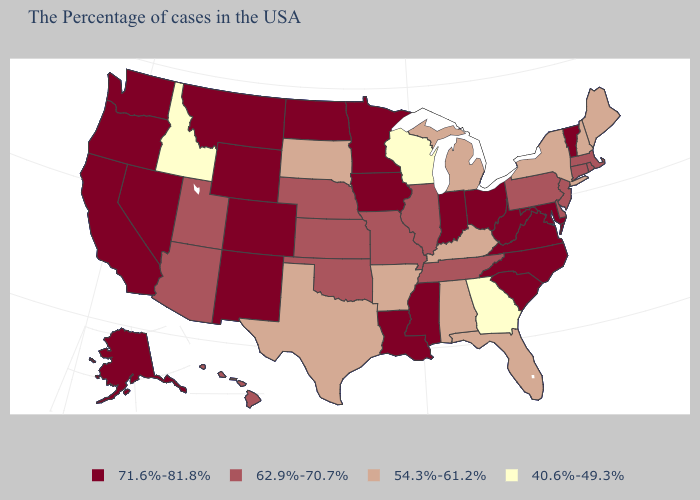Name the states that have a value in the range 40.6%-49.3%?
Write a very short answer. Georgia, Wisconsin, Idaho. Does Ohio have a lower value than North Carolina?
Quick response, please. No. Name the states that have a value in the range 71.6%-81.8%?
Keep it brief. Vermont, Maryland, Virginia, North Carolina, South Carolina, West Virginia, Ohio, Indiana, Mississippi, Louisiana, Minnesota, Iowa, North Dakota, Wyoming, Colorado, New Mexico, Montana, Nevada, California, Washington, Oregon, Alaska. What is the value of South Carolina?
Be succinct. 71.6%-81.8%. Does the map have missing data?
Answer briefly. No. Name the states that have a value in the range 62.9%-70.7%?
Write a very short answer. Massachusetts, Rhode Island, Connecticut, New Jersey, Delaware, Pennsylvania, Tennessee, Illinois, Missouri, Kansas, Nebraska, Oklahoma, Utah, Arizona, Hawaii. Among the states that border Nebraska , does Kansas have the highest value?
Short answer required. No. Does Oregon have the lowest value in the West?
Answer briefly. No. Among the states that border Oklahoma , which have the highest value?
Answer briefly. Colorado, New Mexico. How many symbols are there in the legend?
Give a very brief answer. 4. Name the states that have a value in the range 40.6%-49.3%?
Keep it brief. Georgia, Wisconsin, Idaho. Name the states that have a value in the range 62.9%-70.7%?
Short answer required. Massachusetts, Rhode Island, Connecticut, New Jersey, Delaware, Pennsylvania, Tennessee, Illinois, Missouri, Kansas, Nebraska, Oklahoma, Utah, Arizona, Hawaii. Does Idaho have the lowest value in the USA?
Keep it brief. Yes. What is the value of Arizona?
Write a very short answer. 62.9%-70.7%. What is the lowest value in states that border Iowa?
Answer briefly. 40.6%-49.3%. 